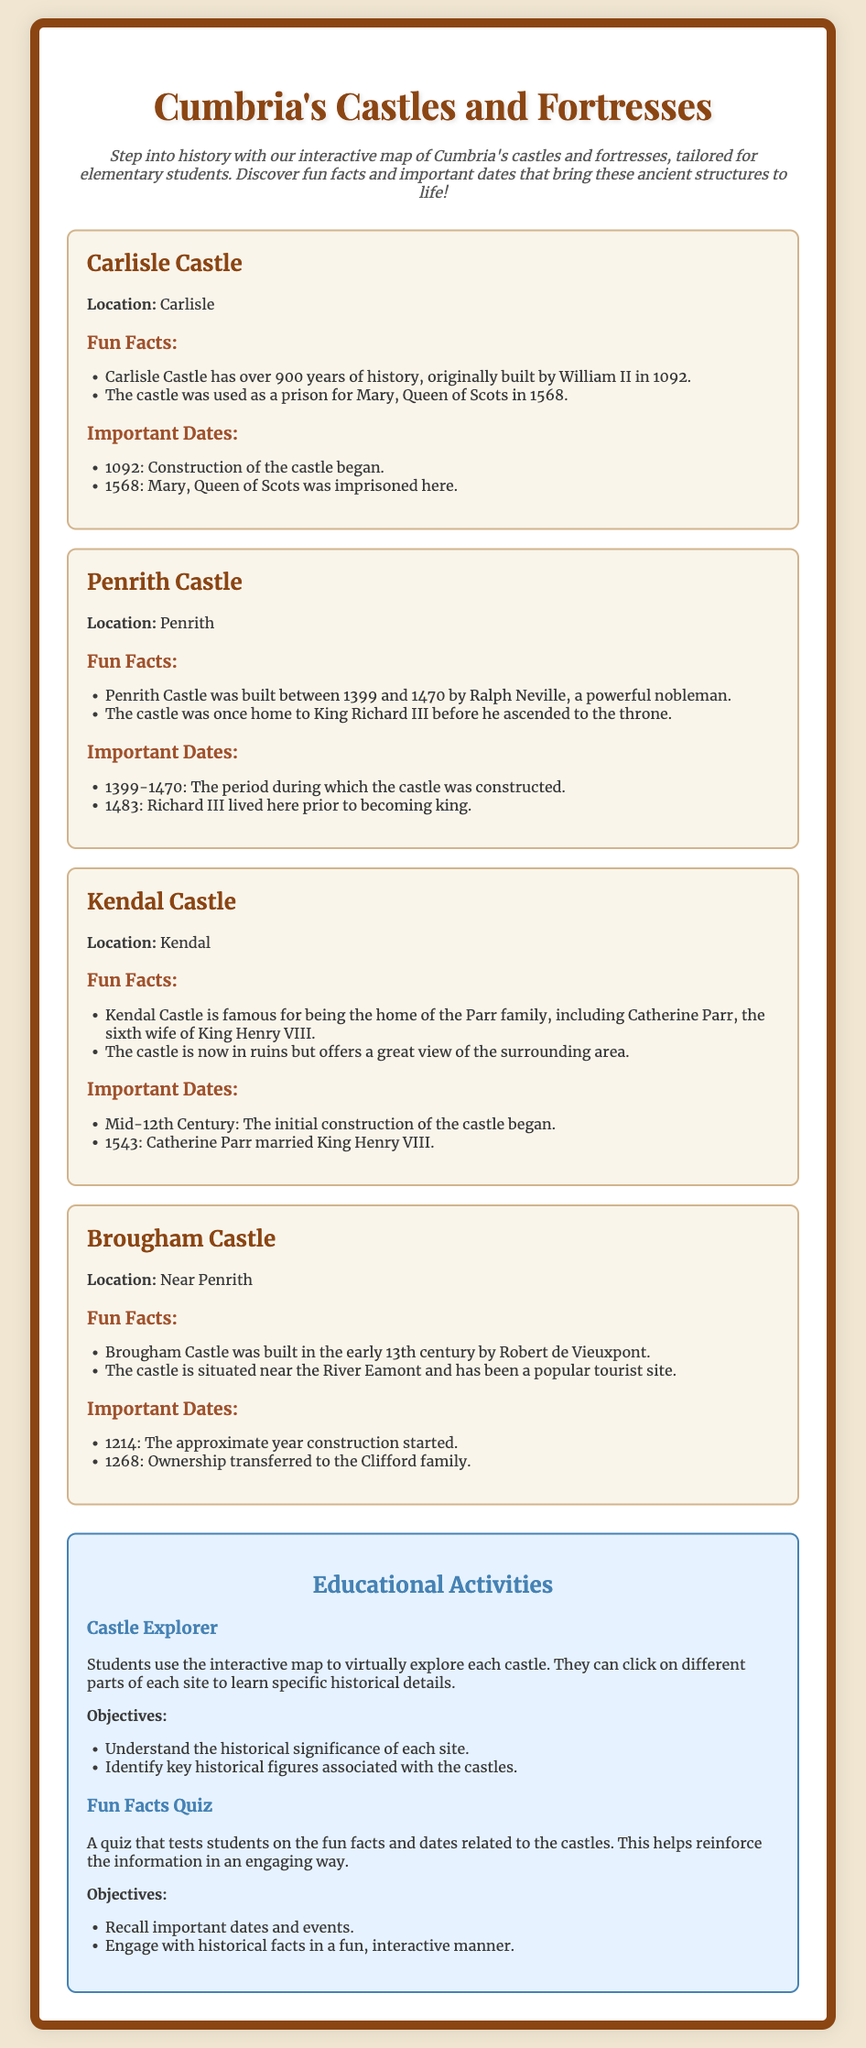What year was Carlisle Castle built? The document states that Carlisle Castle was originally built by William II in 1092.
Answer: 1092 Who was imprisoned in Carlisle Castle? The document mentions that Mary, Queen of Scots was imprisoned at Carlisle Castle in 1568.
Answer: Mary, Queen of Scots How long did it take to build Penrith Castle? The document indicates that Penrith Castle was built between 1399 and 1470, which is a period of 71 years.
Answer: 71 years What significant event happened in 1543 related to Kendal Castle? The document notes that Catherine Parr married King Henry VIII in 1543, while discussing Kendal Castle.
Answer: Catherine Parr married King Henry VIII Who built Brougham Castle? The document states that Brougham Castle was built by Robert de Vieuxpont in the early 13th century.
Answer: Robert de Vieuxpont What is the primary educational activity mentioned in the document? The document lists "Castle Explorer" as the primary educational activity for students.
Answer: Castle Explorer What is one objective of the Fun Facts Quiz activity? The document mentions recalling important dates and events as one of the quiz objectives.
Answer: Recall important dates and events In what century did the construction of Kendal Castle begin? The document indicates that the initial construction of Kendal Castle began in the mid-12th Century.
Answer: Mid-12th Century What color is the background of the playbill? The document describes the background color of the playbill as #f0e6d2.
Answer: #f0e6d2 